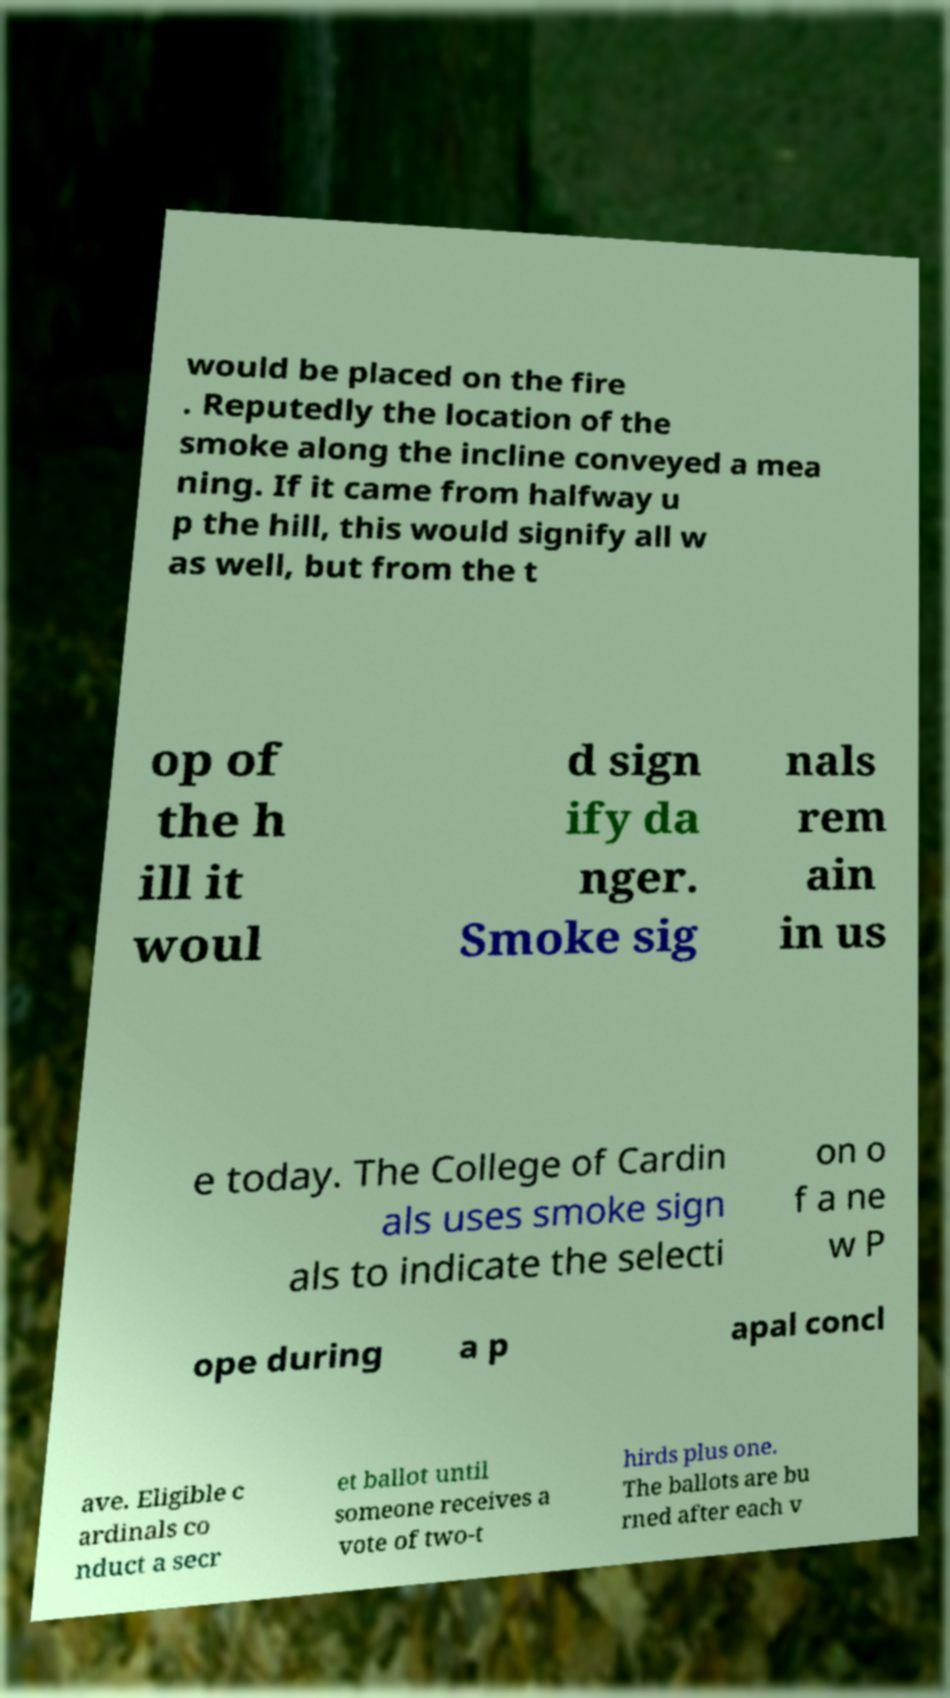Please read and relay the text visible in this image. What does it say? would be placed on the fire . Reputedly the location of the smoke along the incline conveyed a mea ning. If it came from halfway u p the hill, this would signify all w as well, but from the t op of the h ill it woul d sign ify da nger. Smoke sig nals rem ain in us e today. The College of Cardin als uses smoke sign als to indicate the selecti on o f a ne w P ope during a p apal concl ave. Eligible c ardinals co nduct a secr et ballot until someone receives a vote of two-t hirds plus one. The ballots are bu rned after each v 